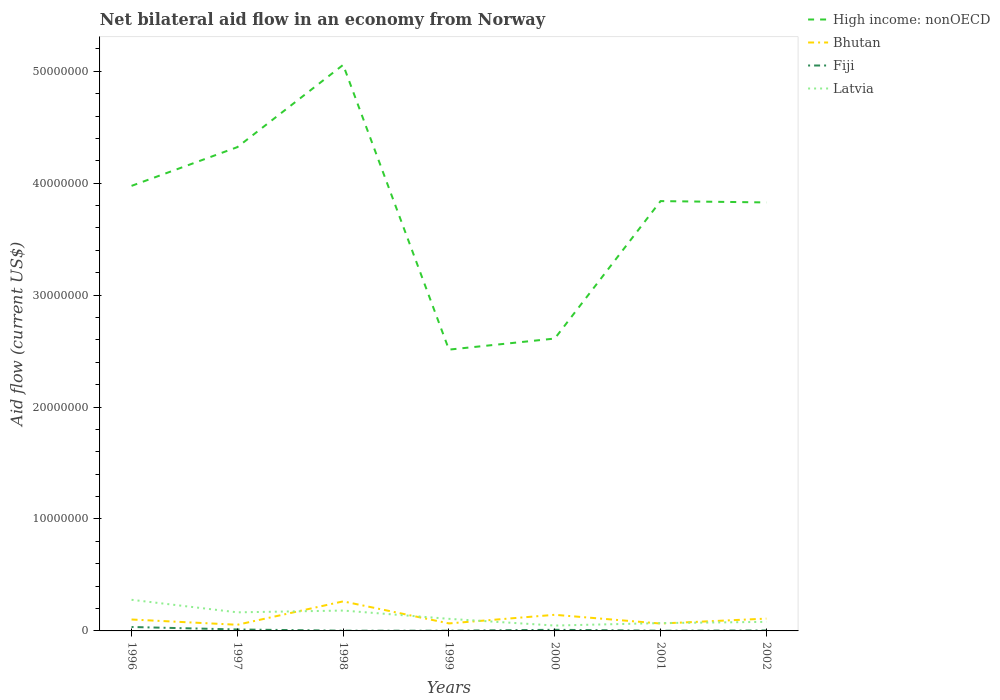Across all years, what is the maximum net bilateral aid flow in Bhutan?
Your response must be concise. 5.50e+05. In which year was the net bilateral aid flow in Bhutan maximum?
Offer a terse response. 1997. What is the total net bilateral aid flow in Fiji in the graph?
Offer a very short reply. 8.00e+04. What is the difference between the highest and the second highest net bilateral aid flow in Latvia?
Make the answer very short. 2.30e+06. How many lines are there?
Make the answer very short. 4. How many years are there in the graph?
Offer a very short reply. 7. Are the values on the major ticks of Y-axis written in scientific E-notation?
Offer a very short reply. No. Does the graph contain any zero values?
Make the answer very short. No. Does the graph contain grids?
Your answer should be compact. No. How many legend labels are there?
Ensure brevity in your answer.  4. What is the title of the graph?
Your answer should be compact. Net bilateral aid flow in an economy from Norway. Does "Switzerland" appear as one of the legend labels in the graph?
Your answer should be very brief. No. What is the label or title of the X-axis?
Offer a very short reply. Years. What is the Aid flow (current US$) of High income: nonOECD in 1996?
Your response must be concise. 3.98e+07. What is the Aid flow (current US$) of Bhutan in 1996?
Provide a short and direct response. 1.02e+06. What is the Aid flow (current US$) in Latvia in 1996?
Keep it short and to the point. 2.78e+06. What is the Aid flow (current US$) of High income: nonOECD in 1997?
Provide a succinct answer. 4.32e+07. What is the Aid flow (current US$) of Bhutan in 1997?
Provide a succinct answer. 5.50e+05. What is the Aid flow (current US$) in Latvia in 1997?
Your answer should be compact. 1.66e+06. What is the Aid flow (current US$) in High income: nonOECD in 1998?
Provide a short and direct response. 5.06e+07. What is the Aid flow (current US$) of Bhutan in 1998?
Give a very brief answer. 2.64e+06. What is the Aid flow (current US$) of Fiji in 1998?
Ensure brevity in your answer.  2.00e+04. What is the Aid flow (current US$) in Latvia in 1998?
Offer a very short reply. 1.82e+06. What is the Aid flow (current US$) of High income: nonOECD in 1999?
Make the answer very short. 2.51e+07. What is the Aid flow (current US$) in Bhutan in 1999?
Give a very brief answer. 6.70e+05. What is the Aid flow (current US$) of Fiji in 1999?
Make the answer very short. 2.00e+04. What is the Aid flow (current US$) of Latvia in 1999?
Offer a terse response. 1.08e+06. What is the Aid flow (current US$) of High income: nonOECD in 2000?
Your answer should be compact. 2.61e+07. What is the Aid flow (current US$) in Bhutan in 2000?
Your answer should be very brief. 1.44e+06. What is the Aid flow (current US$) in Fiji in 2000?
Offer a terse response. 1.00e+05. What is the Aid flow (current US$) in High income: nonOECD in 2001?
Offer a terse response. 3.84e+07. What is the Aid flow (current US$) of Bhutan in 2001?
Keep it short and to the point. 6.60e+05. What is the Aid flow (current US$) of Fiji in 2001?
Your answer should be compact. 2.00e+04. What is the Aid flow (current US$) in Latvia in 2001?
Give a very brief answer. 7.00e+05. What is the Aid flow (current US$) in High income: nonOECD in 2002?
Your response must be concise. 3.83e+07. What is the Aid flow (current US$) in Bhutan in 2002?
Offer a very short reply. 1.10e+06. What is the Aid flow (current US$) of Fiji in 2002?
Make the answer very short. 4.00e+04. What is the Aid flow (current US$) in Latvia in 2002?
Your answer should be compact. 8.10e+05. Across all years, what is the maximum Aid flow (current US$) in High income: nonOECD?
Ensure brevity in your answer.  5.06e+07. Across all years, what is the maximum Aid flow (current US$) in Bhutan?
Offer a terse response. 2.64e+06. Across all years, what is the maximum Aid flow (current US$) of Fiji?
Your answer should be compact. 3.50e+05. Across all years, what is the maximum Aid flow (current US$) in Latvia?
Your response must be concise. 2.78e+06. Across all years, what is the minimum Aid flow (current US$) of High income: nonOECD?
Your response must be concise. 2.51e+07. Across all years, what is the minimum Aid flow (current US$) of Bhutan?
Make the answer very short. 5.50e+05. Across all years, what is the minimum Aid flow (current US$) in Fiji?
Give a very brief answer. 2.00e+04. Across all years, what is the minimum Aid flow (current US$) in Latvia?
Your answer should be very brief. 4.80e+05. What is the total Aid flow (current US$) of High income: nonOECD in the graph?
Your answer should be very brief. 2.61e+08. What is the total Aid flow (current US$) of Bhutan in the graph?
Offer a terse response. 8.08e+06. What is the total Aid flow (current US$) in Fiji in the graph?
Offer a very short reply. 6.80e+05. What is the total Aid flow (current US$) in Latvia in the graph?
Give a very brief answer. 9.33e+06. What is the difference between the Aid flow (current US$) of High income: nonOECD in 1996 and that in 1997?
Give a very brief answer. -3.46e+06. What is the difference between the Aid flow (current US$) in Bhutan in 1996 and that in 1997?
Give a very brief answer. 4.70e+05. What is the difference between the Aid flow (current US$) of Latvia in 1996 and that in 1997?
Your answer should be compact. 1.12e+06. What is the difference between the Aid flow (current US$) of High income: nonOECD in 1996 and that in 1998?
Offer a very short reply. -1.08e+07. What is the difference between the Aid flow (current US$) in Bhutan in 1996 and that in 1998?
Offer a terse response. -1.62e+06. What is the difference between the Aid flow (current US$) in Latvia in 1996 and that in 1998?
Keep it short and to the point. 9.60e+05. What is the difference between the Aid flow (current US$) of High income: nonOECD in 1996 and that in 1999?
Make the answer very short. 1.46e+07. What is the difference between the Aid flow (current US$) in Fiji in 1996 and that in 1999?
Give a very brief answer. 3.30e+05. What is the difference between the Aid flow (current US$) in Latvia in 1996 and that in 1999?
Provide a short and direct response. 1.70e+06. What is the difference between the Aid flow (current US$) in High income: nonOECD in 1996 and that in 2000?
Give a very brief answer. 1.36e+07. What is the difference between the Aid flow (current US$) of Bhutan in 1996 and that in 2000?
Offer a very short reply. -4.20e+05. What is the difference between the Aid flow (current US$) of Latvia in 1996 and that in 2000?
Give a very brief answer. 2.30e+06. What is the difference between the Aid flow (current US$) of High income: nonOECD in 1996 and that in 2001?
Keep it short and to the point. 1.36e+06. What is the difference between the Aid flow (current US$) in Bhutan in 1996 and that in 2001?
Offer a very short reply. 3.60e+05. What is the difference between the Aid flow (current US$) of Fiji in 1996 and that in 2001?
Provide a short and direct response. 3.30e+05. What is the difference between the Aid flow (current US$) in Latvia in 1996 and that in 2001?
Your answer should be compact. 2.08e+06. What is the difference between the Aid flow (current US$) in High income: nonOECD in 1996 and that in 2002?
Your answer should be very brief. 1.48e+06. What is the difference between the Aid flow (current US$) in Bhutan in 1996 and that in 2002?
Offer a terse response. -8.00e+04. What is the difference between the Aid flow (current US$) of Fiji in 1996 and that in 2002?
Provide a succinct answer. 3.10e+05. What is the difference between the Aid flow (current US$) of Latvia in 1996 and that in 2002?
Give a very brief answer. 1.97e+06. What is the difference between the Aid flow (current US$) of High income: nonOECD in 1997 and that in 1998?
Your answer should be compact. -7.35e+06. What is the difference between the Aid flow (current US$) in Bhutan in 1997 and that in 1998?
Offer a very short reply. -2.09e+06. What is the difference between the Aid flow (current US$) in Fiji in 1997 and that in 1998?
Offer a terse response. 1.10e+05. What is the difference between the Aid flow (current US$) in High income: nonOECD in 1997 and that in 1999?
Ensure brevity in your answer.  1.81e+07. What is the difference between the Aid flow (current US$) of Bhutan in 1997 and that in 1999?
Provide a short and direct response. -1.20e+05. What is the difference between the Aid flow (current US$) of Fiji in 1997 and that in 1999?
Your answer should be compact. 1.10e+05. What is the difference between the Aid flow (current US$) in Latvia in 1997 and that in 1999?
Provide a short and direct response. 5.80e+05. What is the difference between the Aid flow (current US$) of High income: nonOECD in 1997 and that in 2000?
Provide a succinct answer. 1.71e+07. What is the difference between the Aid flow (current US$) in Bhutan in 1997 and that in 2000?
Your response must be concise. -8.90e+05. What is the difference between the Aid flow (current US$) in Latvia in 1997 and that in 2000?
Provide a short and direct response. 1.18e+06. What is the difference between the Aid flow (current US$) of High income: nonOECD in 1997 and that in 2001?
Your answer should be very brief. 4.82e+06. What is the difference between the Aid flow (current US$) in Fiji in 1997 and that in 2001?
Keep it short and to the point. 1.10e+05. What is the difference between the Aid flow (current US$) of Latvia in 1997 and that in 2001?
Offer a terse response. 9.60e+05. What is the difference between the Aid flow (current US$) in High income: nonOECD in 1997 and that in 2002?
Offer a terse response. 4.94e+06. What is the difference between the Aid flow (current US$) in Bhutan in 1997 and that in 2002?
Offer a very short reply. -5.50e+05. What is the difference between the Aid flow (current US$) of Latvia in 1997 and that in 2002?
Offer a terse response. 8.50e+05. What is the difference between the Aid flow (current US$) in High income: nonOECD in 1998 and that in 1999?
Ensure brevity in your answer.  2.54e+07. What is the difference between the Aid flow (current US$) of Bhutan in 1998 and that in 1999?
Provide a succinct answer. 1.97e+06. What is the difference between the Aid flow (current US$) in Fiji in 1998 and that in 1999?
Your response must be concise. 0. What is the difference between the Aid flow (current US$) of Latvia in 1998 and that in 1999?
Offer a very short reply. 7.40e+05. What is the difference between the Aid flow (current US$) of High income: nonOECD in 1998 and that in 2000?
Keep it short and to the point. 2.44e+07. What is the difference between the Aid flow (current US$) in Bhutan in 1998 and that in 2000?
Make the answer very short. 1.20e+06. What is the difference between the Aid flow (current US$) of Latvia in 1998 and that in 2000?
Provide a succinct answer. 1.34e+06. What is the difference between the Aid flow (current US$) in High income: nonOECD in 1998 and that in 2001?
Provide a succinct answer. 1.22e+07. What is the difference between the Aid flow (current US$) of Bhutan in 1998 and that in 2001?
Your answer should be compact. 1.98e+06. What is the difference between the Aid flow (current US$) in Fiji in 1998 and that in 2001?
Your answer should be compact. 0. What is the difference between the Aid flow (current US$) of Latvia in 1998 and that in 2001?
Ensure brevity in your answer.  1.12e+06. What is the difference between the Aid flow (current US$) in High income: nonOECD in 1998 and that in 2002?
Your answer should be very brief. 1.23e+07. What is the difference between the Aid flow (current US$) of Bhutan in 1998 and that in 2002?
Provide a short and direct response. 1.54e+06. What is the difference between the Aid flow (current US$) in Fiji in 1998 and that in 2002?
Your response must be concise. -2.00e+04. What is the difference between the Aid flow (current US$) in Latvia in 1998 and that in 2002?
Provide a short and direct response. 1.01e+06. What is the difference between the Aid flow (current US$) of High income: nonOECD in 1999 and that in 2000?
Give a very brief answer. -9.90e+05. What is the difference between the Aid flow (current US$) of Bhutan in 1999 and that in 2000?
Give a very brief answer. -7.70e+05. What is the difference between the Aid flow (current US$) in Fiji in 1999 and that in 2000?
Make the answer very short. -8.00e+04. What is the difference between the Aid flow (current US$) of High income: nonOECD in 1999 and that in 2001?
Provide a succinct answer. -1.33e+07. What is the difference between the Aid flow (current US$) in Fiji in 1999 and that in 2001?
Make the answer very short. 0. What is the difference between the Aid flow (current US$) of Latvia in 1999 and that in 2001?
Make the answer very short. 3.80e+05. What is the difference between the Aid flow (current US$) in High income: nonOECD in 1999 and that in 2002?
Make the answer very short. -1.32e+07. What is the difference between the Aid flow (current US$) in Bhutan in 1999 and that in 2002?
Offer a terse response. -4.30e+05. What is the difference between the Aid flow (current US$) in Fiji in 1999 and that in 2002?
Give a very brief answer. -2.00e+04. What is the difference between the Aid flow (current US$) in Latvia in 1999 and that in 2002?
Provide a short and direct response. 2.70e+05. What is the difference between the Aid flow (current US$) of High income: nonOECD in 2000 and that in 2001?
Ensure brevity in your answer.  -1.23e+07. What is the difference between the Aid flow (current US$) of Bhutan in 2000 and that in 2001?
Give a very brief answer. 7.80e+05. What is the difference between the Aid flow (current US$) of Latvia in 2000 and that in 2001?
Provide a succinct answer. -2.20e+05. What is the difference between the Aid flow (current US$) of High income: nonOECD in 2000 and that in 2002?
Ensure brevity in your answer.  -1.22e+07. What is the difference between the Aid flow (current US$) of Bhutan in 2000 and that in 2002?
Your answer should be compact. 3.40e+05. What is the difference between the Aid flow (current US$) of Fiji in 2000 and that in 2002?
Ensure brevity in your answer.  6.00e+04. What is the difference between the Aid flow (current US$) in Latvia in 2000 and that in 2002?
Your answer should be compact. -3.30e+05. What is the difference between the Aid flow (current US$) of Bhutan in 2001 and that in 2002?
Your answer should be compact. -4.40e+05. What is the difference between the Aid flow (current US$) in Fiji in 2001 and that in 2002?
Provide a short and direct response. -2.00e+04. What is the difference between the Aid flow (current US$) of Latvia in 2001 and that in 2002?
Keep it short and to the point. -1.10e+05. What is the difference between the Aid flow (current US$) of High income: nonOECD in 1996 and the Aid flow (current US$) of Bhutan in 1997?
Your response must be concise. 3.92e+07. What is the difference between the Aid flow (current US$) in High income: nonOECD in 1996 and the Aid flow (current US$) in Fiji in 1997?
Your answer should be very brief. 3.96e+07. What is the difference between the Aid flow (current US$) of High income: nonOECD in 1996 and the Aid flow (current US$) of Latvia in 1997?
Your response must be concise. 3.81e+07. What is the difference between the Aid flow (current US$) in Bhutan in 1996 and the Aid flow (current US$) in Fiji in 1997?
Keep it short and to the point. 8.90e+05. What is the difference between the Aid flow (current US$) of Bhutan in 1996 and the Aid flow (current US$) of Latvia in 1997?
Your answer should be compact. -6.40e+05. What is the difference between the Aid flow (current US$) of Fiji in 1996 and the Aid flow (current US$) of Latvia in 1997?
Your answer should be very brief. -1.31e+06. What is the difference between the Aid flow (current US$) of High income: nonOECD in 1996 and the Aid flow (current US$) of Bhutan in 1998?
Your answer should be compact. 3.71e+07. What is the difference between the Aid flow (current US$) of High income: nonOECD in 1996 and the Aid flow (current US$) of Fiji in 1998?
Provide a succinct answer. 3.97e+07. What is the difference between the Aid flow (current US$) of High income: nonOECD in 1996 and the Aid flow (current US$) of Latvia in 1998?
Your answer should be very brief. 3.79e+07. What is the difference between the Aid flow (current US$) of Bhutan in 1996 and the Aid flow (current US$) of Latvia in 1998?
Provide a short and direct response. -8.00e+05. What is the difference between the Aid flow (current US$) of Fiji in 1996 and the Aid flow (current US$) of Latvia in 1998?
Provide a succinct answer. -1.47e+06. What is the difference between the Aid flow (current US$) of High income: nonOECD in 1996 and the Aid flow (current US$) of Bhutan in 1999?
Provide a short and direct response. 3.91e+07. What is the difference between the Aid flow (current US$) in High income: nonOECD in 1996 and the Aid flow (current US$) in Fiji in 1999?
Your response must be concise. 3.97e+07. What is the difference between the Aid flow (current US$) in High income: nonOECD in 1996 and the Aid flow (current US$) in Latvia in 1999?
Ensure brevity in your answer.  3.87e+07. What is the difference between the Aid flow (current US$) in Fiji in 1996 and the Aid flow (current US$) in Latvia in 1999?
Provide a short and direct response. -7.30e+05. What is the difference between the Aid flow (current US$) of High income: nonOECD in 1996 and the Aid flow (current US$) of Bhutan in 2000?
Give a very brief answer. 3.83e+07. What is the difference between the Aid flow (current US$) in High income: nonOECD in 1996 and the Aid flow (current US$) in Fiji in 2000?
Offer a very short reply. 3.97e+07. What is the difference between the Aid flow (current US$) of High income: nonOECD in 1996 and the Aid flow (current US$) of Latvia in 2000?
Make the answer very short. 3.93e+07. What is the difference between the Aid flow (current US$) of Bhutan in 1996 and the Aid flow (current US$) of Fiji in 2000?
Your answer should be compact. 9.20e+05. What is the difference between the Aid flow (current US$) in Bhutan in 1996 and the Aid flow (current US$) in Latvia in 2000?
Ensure brevity in your answer.  5.40e+05. What is the difference between the Aid flow (current US$) in Fiji in 1996 and the Aid flow (current US$) in Latvia in 2000?
Provide a short and direct response. -1.30e+05. What is the difference between the Aid flow (current US$) in High income: nonOECD in 1996 and the Aid flow (current US$) in Bhutan in 2001?
Offer a very short reply. 3.91e+07. What is the difference between the Aid flow (current US$) in High income: nonOECD in 1996 and the Aid flow (current US$) in Fiji in 2001?
Give a very brief answer. 3.97e+07. What is the difference between the Aid flow (current US$) of High income: nonOECD in 1996 and the Aid flow (current US$) of Latvia in 2001?
Provide a short and direct response. 3.91e+07. What is the difference between the Aid flow (current US$) in Fiji in 1996 and the Aid flow (current US$) in Latvia in 2001?
Offer a terse response. -3.50e+05. What is the difference between the Aid flow (current US$) in High income: nonOECD in 1996 and the Aid flow (current US$) in Bhutan in 2002?
Make the answer very short. 3.87e+07. What is the difference between the Aid flow (current US$) of High income: nonOECD in 1996 and the Aid flow (current US$) of Fiji in 2002?
Ensure brevity in your answer.  3.97e+07. What is the difference between the Aid flow (current US$) in High income: nonOECD in 1996 and the Aid flow (current US$) in Latvia in 2002?
Your response must be concise. 3.90e+07. What is the difference between the Aid flow (current US$) of Bhutan in 1996 and the Aid flow (current US$) of Fiji in 2002?
Your answer should be compact. 9.80e+05. What is the difference between the Aid flow (current US$) of Fiji in 1996 and the Aid flow (current US$) of Latvia in 2002?
Ensure brevity in your answer.  -4.60e+05. What is the difference between the Aid flow (current US$) of High income: nonOECD in 1997 and the Aid flow (current US$) of Bhutan in 1998?
Make the answer very short. 4.06e+07. What is the difference between the Aid flow (current US$) of High income: nonOECD in 1997 and the Aid flow (current US$) of Fiji in 1998?
Provide a short and direct response. 4.32e+07. What is the difference between the Aid flow (current US$) of High income: nonOECD in 1997 and the Aid flow (current US$) of Latvia in 1998?
Keep it short and to the point. 4.14e+07. What is the difference between the Aid flow (current US$) in Bhutan in 1997 and the Aid flow (current US$) in Fiji in 1998?
Your answer should be very brief. 5.30e+05. What is the difference between the Aid flow (current US$) of Bhutan in 1997 and the Aid flow (current US$) of Latvia in 1998?
Your answer should be very brief. -1.27e+06. What is the difference between the Aid flow (current US$) of Fiji in 1997 and the Aid flow (current US$) of Latvia in 1998?
Your answer should be very brief. -1.69e+06. What is the difference between the Aid flow (current US$) in High income: nonOECD in 1997 and the Aid flow (current US$) in Bhutan in 1999?
Offer a terse response. 4.26e+07. What is the difference between the Aid flow (current US$) in High income: nonOECD in 1997 and the Aid flow (current US$) in Fiji in 1999?
Your answer should be very brief. 4.32e+07. What is the difference between the Aid flow (current US$) of High income: nonOECD in 1997 and the Aid flow (current US$) of Latvia in 1999?
Your answer should be very brief. 4.21e+07. What is the difference between the Aid flow (current US$) of Bhutan in 1997 and the Aid flow (current US$) of Fiji in 1999?
Provide a succinct answer. 5.30e+05. What is the difference between the Aid flow (current US$) of Bhutan in 1997 and the Aid flow (current US$) of Latvia in 1999?
Keep it short and to the point. -5.30e+05. What is the difference between the Aid flow (current US$) in Fiji in 1997 and the Aid flow (current US$) in Latvia in 1999?
Keep it short and to the point. -9.50e+05. What is the difference between the Aid flow (current US$) in High income: nonOECD in 1997 and the Aid flow (current US$) in Bhutan in 2000?
Provide a short and direct response. 4.18e+07. What is the difference between the Aid flow (current US$) of High income: nonOECD in 1997 and the Aid flow (current US$) of Fiji in 2000?
Ensure brevity in your answer.  4.31e+07. What is the difference between the Aid flow (current US$) in High income: nonOECD in 1997 and the Aid flow (current US$) in Latvia in 2000?
Ensure brevity in your answer.  4.27e+07. What is the difference between the Aid flow (current US$) in Bhutan in 1997 and the Aid flow (current US$) in Latvia in 2000?
Your answer should be compact. 7.00e+04. What is the difference between the Aid flow (current US$) of Fiji in 1997 and the Aid flow (current US$) of Latvia in 2000?
Offer a very short reply. -3.50e+05. What is the difference between the Aid flow (current US$) in High income: nonOECD in 1997 and the Aid flow (current US$) in Bhutan in 2001?
Offer a very short reply. 4.26e+07. What is the difference between the Aid flow (current US$) in High income: nonOECD in 1997 and the Aid flow (current US$) in Fiji in 2001?
Offer a very short reply. 4.32e+07. What is the difference between the Aid flow (current US$) of High income: nonOECD in 1997 and the Aid flow (current US$) of Latvia in 2001?
Provide a succinct answer. 4.25e+07. What is the difference between the Aid flow (current US$) in Bhutan in 1997 and the Aid flow (current US$) in Fiji in 2001?
Give a very brief answer. 5.30e+05. What is the difference between the Aid flow (current US$) of Fiji in 1997 and the Aid flow (current US$) of Latvia in 2001?
Ensure brevity in your answer.  -5.70e+05. What is the difference between the Aid flow (current US$) in High income: nonOECD in 1997 and the Aid flow (current US$) in Bhutan in 2002?
Offer a very short reply. 4.21e+07. What is the difference between the Aid flow (current US$) of High income: nonOECD in 1997 and the Aid flow (current US$) of Fiji in 2002?
Your answer should be very brief. 4.32e+07. What is the difference between the Aid flow (current US$) in High income: nonOECD in 1997 and the Aid flow (current US$) in Latvia in 2002?
Your answer should be very brief. 4.24e+07. What is the difference between the Aid flow (current US$) of Bhutan in 1997 and the Aid flow (current US$) of Fiji in 2002?
Give a very brief answer. 5.10e+05. What is the difference between the Aid flow (current US$) in Fiji in 1997 and the Aid flow (current US$) in Latvia in 2002?
Your answer should be very brief. -6.80e+05. What is the difference between the Aid flow (current US$) in High income: nonOECD in 1998 and the Aid flow (current US$) in Bhutan in 1999?
Offer a very short reply. 4.99e+07. What is the difference between the Aid flow (current US$) in High income: nonOECD in 1998 and the Aid flow (current US$) in Fiji in 1999?
Ensure brevity in your answer.  5.06e+07. What is the difference between the Aid flow (current US$) in High income: nonOECD in 1998 and the Aid flow (current US$) in Latvia in 1999?
Provide a succinct answer. 4.95e+07. What is the difference between the Aid flow (current US$) in Bhutan in 1998 and the Aid flow (current US$) in Fiji in 1999?
Offer a terse response. 2.62e+06. What is the difference between the Aid flow (current US$) of Bhutan in 1998 and the Aid flow (current US$) of Latvia in 1999?
Offer a terse response. 1.56e+06. What is the difference between the Aid flow (current US$) in Fiji in 1998 and the Aid flow (current US$) in Latvia in 1999?
Make the answer very short. -1.06e+06. What is the difference between the Aid flow (current US$) of High income: nonOECD in 1998 and the Aid flow (current US$) of Bhutan in 2000?
Provide a short and direct response. 4.91e+07. What is the difference between the Aid flow (current US$) of High income: nonOECD in 1998 and the Aid flow (current US$) of Fiji in 2000?
Make the answer very short. 5.05e+07. What is the difference between the Aid flow (current US$) of High income: nonOECD in 1998 and the Aid flow (current US$) of Latvia in 2000?
Ensure brevity in your answer.  5.01e+07. What is the difference between the Aid flow (current US$) in Bhutan in 1998 and the Aid flow (current US$) in Fiji in 2000?
Provide a short and direct response. 2.54e+06. What is the difference between the Aid flow (current US$) in Bhutan in 1998 and the Aid flow (current US$) in Latvia in 2000?
Make the answer very short. 2.16e+06. What is the difference between the Aid flow (current US$) in Fiji in 1998 and the Aid flow (current US$) in Latvia in 2000?
Offer a very short reply. -4.60e+05. What is the difference between the Aid flow (current US$) of High income: nonOECD in 1998 and the Aid flow (current US$) of Bhutan in 2001?
Your response must be concise. 4.99e+07. What is the difference between the Aid flow (current US$) of High income: nonOECD in 1998 and the Aid flow (current US$) of Fiji in 2001?
Offer a terse response. 5.06e+07. What is the difference between the Aid flow (current US$) in High income: nonOECD in 1998 and the Aid flow (current US$) in Latvia in 2001?
Keep it short and to the point. 4.99e+07. What is the difference between the Aid flow (current US$) in Bhutan in 1998 and the Aid flow (current US$) in Fiji in 2001?
Offer a terse response. 2.62e+06. What is the difference between the Aid flow (current US$) of Bhutan in 1998 and the Aid flow (current US$) of Latvia in 2001?
Ensure brevity in your answer.  1.94e+06. What is the difference between the Aid flow (current US$) in Fiji in 1998 and the Aid flow (current US$) in Latvia in 2001?
Provide a succinct answer. -6.80e+05. What is the difference between the Aid flow (current US$) in High income: nonOECD in 1998 and the Aid flow (current US$) in Bhutan in 2002?
Your answer should be very brief. 4.95e+07. What is the difference between the Aid flow (current US$) of High income: nonOECD in 1998 and the Aid flow (current US$) of Fiji in 2002?
Your answer should be compact. 5.05e+07. What is the difference between the Aid flow (current US$) of High income: nonOECD in 1998 and the Aid flow (current US$) of Latvia in 2002?
Provide a succinct answer. 4.98e+07. What is the difference between the Aid flow (current US$) in Bhutan in 1998 and the Aid flow (current US$) in Fiji in 2002?
Your response must be concise. 2.60e+06. What is the difference between the Aid flow (current US$) in Bhutan in 1998 and the Aid flow (current US$) in Latvia in 2002?
Your response must be concise. 1.83e+06. What is the difference between the Aid flow (current US$) of Fiji in 1998 and the Aid flow (current US$) of Latvia in 2002?
Your answer should be compact. -7.90e+05. What is the difference between the Aid flow (current US$) in High income: nonOECD in 1999 and the Aid flow (current US$) in Bhutan in 2000?
Offer a terse response. 2.37e+07. What is the difference between the Aid flow (current US$) of High income: nonOECD in 1999 and the Aid flow (current US$) of Fiji in 2000?
Make the answer very short. 2.50e+07. What is the difference between the Aid flow (current US$) of High income: nonOECD in 1999 and the Aid flow (current US$) of Latvia in 2000?
Your answer should be very brief. 2.46e+07. What is the difference between the Aid flow (current US$) of Bhutan in 1999 and the Aid flow (current US$) of Fiji in 2000?
Provide a short and direct response. 5.70e+05. What is the difference between the Aid flow (current US$) in Bhutan in 1999 and the Aid flow (current US$) in Latvia in 2000?
Your answer should be very brief. 1.90e+05. What is the difference between the Aid flow (current US$) of Fiji in 1999 and the Aid flow (current US$) of Latvia in 2000?
Your response must be concise. -4.60e+05. What is the difference between the Aid flow (current US$) in High income: nonOECD in 1999 and the Aid flow (current US$) in Bhutan in 2001?
Offer a very short reply. 2.45e+07. What is the difference between the Aid flow (current US$) in High income: nonOECD in 1999 and the Aid flow (current US$) in Fiji in 2001?
Provide a succinct answer. 2.51e+07. What is the difference between the Aid flow (current US$) of High income: nonOECD in 1999 and the Aid flow (current US$) of Latvia in 2001?
Your answer should be very brief. 2.44e+07. What is the difference between the Aid flow (current US$) of Bhutan in 1999 and the Aid flow (current US$) of Fiji in 2001?
Give a very brief answer. 6.50e+05. What is the difference between the Aid flow (current US$) of Fiji in 1999 and the Aid flow (current US$) of Latvia in 2001?
Your answer should be very brief. -6.80e+05. What is the difference between the Aid flow (current US$) of High income: nonOECD in 1999 and the Aid flow (current US$) of Bhutan in 2002?
Your answer should be compact. 2.40e+07. What is the difference between the Aid flow (current US$) of High income: nonOECD in 1999 and the Aid flow (current US$) of Fiji in 2002?
Offer a terse response. 2.51e+07. What is the difference between the Aid flow (current US$) in High income: nonOECD in 1999 and the Aid flow (current US$) in Latvia in 2002?
Provide a short and direct response. 2.43e+07. What is the difference between the Aid flow (current US$) in Bhutan in 1999 and the Aid flow (current US$) in Fiji in 2002?
Offer a terse response. 6.30e+05. What is the difference between the Aid flow (current US$) of Bhutan in 1999 and the Aid flow (current US$) of Latvia in 2002?
Keep it short and to the point. -1.40e+05. What is the difference between the Aid flow (current US$) in Fiji in 1999 and the Aid flow (current US$) in Latvia in 2002?
Offer a terse response. -7.90e+05. What is the difference between the Aid flow (current US$) of High income: nonOECD in 2000 and the Aid flow (current US$) of Bhutan in 2001?
Make the answer very short. 2.55e+07. What is the difference between the Aid flow (current US$) in High income: nonOECD in 2000 and the Aid flow (current US$) in Fiji in 2001?
Your answer should be compact. 2.61e+07. What is the difference between the Aid flow (current US$) of High income: nonOECD in 2000 and the Aid flow (current US$) of Latvia in 2001?
Make the answer very short. 2.54e+07. What is the difference between the Aid flow (current US$) in Bhutan in 2000 and the Aid flow (current US$) in Fiji in 2001?
Your answer should be very brief. 1.42e+06. What is the difference between the Aid flow (current US$) in Bhutan in 2000 and the Aid flow (current US$) in Latvia in 2001?
Offer a terse response. 7.40e+05. What is the difference between the Aid flow (current US$) of Fiji in 2000 and the Aid flow (current US$) of Latvia in 2001?
Your response must be concise. -6.00e+05. What is the difference between the Aid flow (current US$) in High income: nonOECD in 2000 and the Aid flow (current US$) in Bhutan in 2002?
Offer a very short reply. 2.50e+07. What is the difference between the Aid flow (current US$) in High income: nonOECD in 2000 and the Aid flow (current US$) in Fiji in 2002?
Ensure brevity in your answer.  2.61e+07. What is the difference between the Aid flow (current US$) in High income: nonOECD in 2000 and the Aid flow (current US$) in Latvia in 2002?
Make the answer very short. 2.53e+07. What is the difference between the Aid flow (current US$) in Bhutan in 2000 and the Aid flow (current US$) in Fiji in 2002?
Make the answer very short. 1.40e+06. What is the difference between the Aid flow (current US$) in Bhutan in 2000 and the Aid flow (current US$) in Latvia in 2002?
Your answer should be very brief. 6.30e+05. What is the difference between the Aid flow (current US$) in Fiji in 2000 and the Aid flow (current US$) in Latvia in 2002?
Your response must be concise. -7.10e+05. What is the difference between the Aid flow (current US$) of High income: nonOECD in 2001 and the Aid flow (current US$) of Bhutan in 2002?
Offer a very short reply. 3.73e+07. What is the difference between the Aid flow (current US$) of High income: nonOECD in 2001 and the Aid flow (current US$) of Fiji in 2002?
Provide a succinct answer. 3.84e+07. What is the difference between the Aid flow (current US$) of High income: nonOECD in 2001 and the Aid flow (current US$) of Latvia in 2002?
Ensure brevity in your answer.  3.76e+07. What is the difference between the Aid flow (current US$) in Bhutan in 2001 and the Aid flow (current US$) in Fiji in 2002?
Offer a very short reply. 6.20e+05. What is the difference between the Aid flow (current US$) in Fiji in 2001 and the Aid flow (current US$) in Latvia in 2002?
Offer a terse response. -7.90e+05. What is the average Aid flow (current US$) of High income: nonOECD per year?
Offer a very short reply. 3.74e+07. What is the average Aid flow (current US$) of Bhutan per year?
Offer a terse response. 1.15e+06. What is the average Aid flow (current US$) in Fiji per year?
Offer a very short reply. 9.71e+04. What is the average Aid flow (current US$) in Latvia per year?
Your answer should be compact. 1.33e+06. In the year 1996, what is the difference between the Aid flow (current US$) in High income: nonOECD and Aid flow (current US$) in Bhutan?
Give a very brief answer. 3.87e+07. In the year 1996, what is the difference between the Aid flow (current US$) of High income: nonOECD and Aid flow (current US$) of Fiji?
Ensure brevity in your answer.  3.94e+07. In the year 1996, what is the difference between the Aid flow (current US$) of High income: nonOECD and Aid flow (current US$) of Latvia?
Give a very brief answer. 3.70e+07. In the year 1996, what is the difference between the Aid flow (current US$) in Bhutan and Aid flow (current US$) in Fiji?
Your answer should be very brief. 6.70e+05. In the year 1996, what is the difference between the Aid flow (current US$) in Bhutan and Aid flow (current US$) in Latvia?
Offer a terse response. -1.76e+06. In the year 1996, what is the difference between the Aid flow (current US$) of Fiji and Aid flow (current US$) of Latvia?
Your answer should be compact. -2.43e+06. In the year 1997, what is the difference between the Aid flow (current US$) in High income: nonOECD and Aid flow (current US$) in Bhutan?
Keep it short and to the point. 4.27e+07. In the year 1997, what is the difference between the Aid flow (current US$) of High income: nonOECD and Aid flow (current US$) of Fiji?
Give a very brief answer. 4.31e+07. In the year 1997, what is the difference between the Aid flow (current US$) in High income: nonOECD and Aid flow (current US$) in Latvia?
Give a very brief answer. 4.16e+07. In the year 1997, what is the difference between the Aid flow (current US$) of Bhutan and Aid flow (current US$) of Latvia?
Offer a very short reply. -1.11e+06. In the year 1997, what is the difference between the Aid flow (current US$) in Fiji and Aid flow (current US$) in Latvia?
Give a very brief answer. -1.53e+06. In the year 1998, what is the difference between the Aid flow (current US$) of High income: nonOECD and Aid flow (current US$) of Bhutan?
Ensure brevity in your answer.  4.79e+07. In the year 1998, what is the difference between the Aid flow (current US$) in High income: nonOECD and Aid flow (current US$) in Fiji?
Your response must be concise. 5.06e+07. In the year 1998, what is the difference between the Aid flow (current US$) in High income: nonOECD and Aid flow (current US$) in Latvia?
Keep it short and to the point. 4.88e+07. In the year 1998, what is the difference between the Aid flow (current US$) of Bhutan and Aid flow (current US$) of Fiji?
Offer a terse response. 2.62e+06. In the year 1998, what is the difference between the Aid flow (current US$) in Bhutan and Aid flow (current US$) in Latvia?
Make the answer very short. 8.20e+05. In the year 1998, what is the difference between the Aid flow (current US$) of Fiji and Aid flow (current US$) of Latvia?
Keep it short and to the point. -1.80e+06. In the year 1999, what is the difference between the Aid flow (current US$) of High income: nonOECD and Aid flow (current US$) of Bhutan?
Your answer should be very brief. 2.45e+07. In the year 1999, what is the difference between the Aid flow (current US$) in High income: nonOECD and Aid flow (current US$) in Fiji?
Keep it short and to the point. 2.51e+07. In the year 1999, what is the difference between the Aid flow (current US$) in High income: nonOECD and Aid flow (current US$) in Latvia?
Provide a succinct answer. 2.40e+07. In the year 1999, what is the difference between the Aid flow (current US$) of Bhutan and Aid flow (current US$) of Fiji?
Make the answer very short. 6.50e+05. In the year 1999, what is the difference between the Aid flow (current US$) of Bhutan and Aid flow (current US$) of Latvia?
Ensure brevity in your answer.  -4.10e+05. In the year 1999, what is the difference between the Aid flow (current US$) in Fiji and Aid flow (current US$) in Latvia?
Provide a succinct answer. -1.06e+06. In the year 2000, what is the difference between the Aid flow (current US$) in High income: nonOECD and Aid flow (current US$) in Bhutan?
Offer a very short reply. 2.47e+07. In the year 2000, what is the difference between the Aid flow (current US$) of High income: nonOECD and Aid flow (current US$) of Fiji?
Provide a short and direct response. 2.60e+07. In the year 2000, what is the difference between the Aid flow (current US$) in High income: nonOECD and Aid flow (current US$) in Latvia?
Ensure brevity in your answer.  2.56e+07. In the year 2000, what is the difference between the Aid flow (current US$) in Bhutan and Aid flow (current US$) in Fiji?
Keep it short and to the point. 1.34e+06. In the year 2000, what is the difference between the Aid flow (current US$) of Bhutan and Aid flow (current US$) of Latvia?
Ensure brevity in your answer.  9.60e+05. In the year 2000, what is the difference between the Aid flow (current US$) of Fiji and Aid flow (current US$) of Latvia?
Provide a short and direct response. -3.80e+05. In the year 2001, what is the difference between the Aid flow (current US$) in High income: nonOECD and Aid flow (current US$) in Bhutan?
Provide a short and direct response. 3.77e+07. In the year 2001, what is the difference between the Aid flow (current US$) of High income: nonOECD and Aid flow (current US$) of Fiji?
Ensure brevity in your answer.  3.84e+07. In the year 2001, what is the difference between the Aid flow (current US$) of High income: nonOECD and Aid flow (current US$) of Latvia?
Offer a very short reply. 3.77e+07. In the year 2001, what is the difference between the Aid flow (current US$) of Bhutan and Aid flow (current US$) of Fiji?
Provide a succinct answer. 6.40e+05. In the year 2001, what is the difference between the Aid flow (current US$) in Fiji and Aid flow (current US$) in Latvia?
Your response must be concise. -6.80e+05. In the year 2002, what is the difference between the Aid flow (current US$) of High income: nonOECD and Aid flow (current US$) of Bhutan?
Offer a terse response. 3.72e+07. In the year 2002, what is the difference between the Aid flow (current US$) of High income: nonOECD and Aid flow (current US$) of Fiji?
Provide a succinct answer. 3.82e+07. In the year 2002, what is the difference between the Aid flow (current US$) in High income: nonOECD and Aid flow (current US$) in Latvia?
Provide a short and direct response. 3.75e+07. In the year 2002, what is the difference between the Aid flow (current US$) of Bhutan and Aid flow (current US$) of Fiji?
Offer a very short reply. 1.06e+06. In the year 2002, what is the difference between the Aid flow (current US$) in Bhutan and Aid flow (current US$) in Latvia?
Provide a short and direct response. 2.90e+05. In the year 2002, what is the difference between the Aid flow (current US$) in Fiji and Aid flow (current US$) in Latvia?
Give a very brief answer. -7.70e+05. What is the ratio of the Aid flow (current US$) of High income: nonOECD in 1996 to that in 1997?
Make the answer very short. 0.92. What is the ratio of the Aid flow (current US$) of Bhutan in 1996 to that in 1997?
Offer a terse response. 1.85. What is the ratio of the Aid flow (current US$) of Fiji in 1996 to that in 1997?
Provide a short and direct response. 2.69. What is the ratio of the Aid flow (current US$) in Latvia in 1996 to that in 1997?
Offer a terse response. 1.67. What is the ratio of the Aid flow (current US$) of High income: nonOECD in 1996 to that in 1998?
Your answer should be compact. 0.79. What is the ratio of the Aid flow (current US$) of Bhutan in 1996 to that in 1998?
Offer a very short reply. 0.39. What is the ratio of the Aid flow (current US$) in Latvia in 1996 to that in 1998?
Offer a terse response. 1.53. What is the ratio of the Aid flow (current US$) of High income: nonOECD in 1996 to that in 1999?
Provide a succinct answer. 1.58. What is the ratio of the Aid flow (current US$) in Bhutan in 1996 to that in 1999?
Your answer should be compact. 1.52. What is the ratio of the Aid flow (current US$) in Fiji in 1996 to that in 1999?
Offer a terse response. 17.5. What is the ratio of the Aid flow (current US$) in Latvia in 1996 to that in 1999?
Provide a short and direct response. 2.57. What is the ratio of the Aid flow (current US$) of High income: nonOECD in 1996 to that in 2000?
Your answer should be compact. 1.52. What is the ratio of the Aid flow (current US$) of Bhutan in 1996 to that in 2000?
Your answer should be compact. 0.71. What is the ratio of the Aid flow (current US$) in Latvia in 1996 to that in 2000?
Provide a succinct answer. 5.79. What is the ratio of the Aid flow (current US$) in High income: nonOECD in 1996 to that in 2001?
Your answer should be very brief. 1.04. What is the ratio of the Aid flow (current US$) in Bhutan in 1996 to that in 2001?
Offer a terse response. 1.55. What is the ratio of the Aid flow (current US$) in Fiji in 1996 to that in 2001?
Keep it short and to the point. 17.5. What is the ratio of the Aid flow (current US$) of Latvia in 1996 to that in 2001?
Give a very brief answer. 3.97. What is the ratio of the Aid flow (current US$) in High income: nonOECD in 1996 to that in 2002?
Keep it short and to the point. 1.04. What is the ratio of the Aid flow (current US$) of Bhutan in 1996 to that in 2002?
Your answer should be very brief. 0.93. What is the ratio of the Aid flow (current US$) in Fiji in 1996 to that in 2002?
Your answer should be compact. 8.75. What is the ratio of the Aid flow (current US$) in Latvia in 1996 to that in 2002?
Your response must be concise. 3.43. What is the ratio of the Aid flow (current US$) of High income: nonOECD in 1997 to that in 1998?
Offer a terse response. 0.85. What is the ratio of the Aid flow (current US$) in Bhutan in 1997 to that in 1998?
Give a very brief answer. 0.21. What is the ratio of the Aid flow (current US$) of Fiji in 1997 to that in 1998?
Give a very brief answer. 6.5. What is the ratio of the Aid flow (current US$) of Latvia in 1997 to that in 1998?
Provide a succinct answer. 0.91. What is the ratio of the Aid flow (current US$) in High income: nonOECD in 1997 to that in 1999?
Your answer should be compact. 1.72. What is the ratio of the Aid flow (current US$) in Bhutan in 1997 to that in 1999?
Make the answer very short. 0.82. What is the ratio of the Aid flow (current US$) in Fiji in 1997 to that in 1999?
Provide a succinct answer. 6.5. What is the ratio of the Aid flow (current US$) in Latvia in 1997 to that in 1999?
Your answer should be compact. 1.54. What is the ratio of the Aid flow (current US$) of High income: nonOECD in 1997 to that in 2000?
Offer a very short reply. 1.65. What is the ratio of the Aid flow (current US$) in Bhutan in 1997 to that in 2000?
Offer a very short reply. 0.38. What is the ratio of the Aid flow (current US$) in Latvia in 1997 to that in 2000?
Provide a short and direct response. 3.46. What is the ratio of the Aid flow (current US$) of High income: nonOECD in 1997 to that in 2001?
Your response must be concise. 1.13. What is the ratio of the Aid flow (current US$) in Bhutan in 1997 to that in 2001?
Keep it short and to the point. 0.83. What is the ratio of the Aid flow (current US$) of Latvia in 1997 to that in 2001?
Ensure brevity in your answer.  2.37. What is the ratio of the Aid flow (current US$) in High income: nonOECD in 1997 to that in 2002?
Your response must be concise. 1.13. What is the ratio of the Aid flow (current US$) of Fiji in 1997 to that in 2002?
Give a very brief answer. 3.25. What is the ratio of the Aid flow (current US$) in Latvia in 1997 to that in 2002?
Offer a very short reply. 2.05. What is the ratio of the Aid flow (current US$) in High income: nonOECD in 1998 to that in 1999?
Provide a short and direct response. 2.01. What is the ratio of the Aid flow (current US$) of Bhutan in 1998 to that in 1999?
Your answer should be very brief. 3.94. What is the ratio of the Aid flow (current US$) in Fiji in 1998 to that in 1999?
Keep it short and to the point. 1. What is the ratio of the Aid flow (current US$) of Latvia in 1998 to that in 1999?
Offer a very short reply. 1.69. What is the ratio of the Aid flow (current US$) of High income: nonOECD in 1998 to that in 2000?
Make the answer very short. 1.94. What is the ratio of the Aid flow (current US$) of Bhutan in 1998 to that in 2000?
Offer a terse response. 1.83. What is the ratio of the Aid flow (current US$) of Latvia in 1998 to that in 2000?
Provide a short and direct response. 3.79. What is the ratio of the Aid flow (current US$) of High income: nonOECD in 1998 to that in 2001?
Offer a terse response. 1.32. What is the ratio of the Aid flow (current US$) in Bhutan in 1998 to that in 2001?
Offer a terse response. 4. What is the ratio of the Aid flow (current US$) of Fiji in 1998 to that in 2001?
Your response must be concise. 1. What is the ratio of the Aid flow (current US$) of High income: nonOECD in 1998 to that in 2002?
Offer a very short reply. 1.32. What is the ratio of the Aid flow (current US$) in Bhutan in 1998 to that in 2002?
Provide a short and direct response. 2.4. What is the ratio of the Aid flow (current US$) in Fiji in 1998 to that in 2002?
Provide a succinct answer. 0.5. What is the ratio of the Aid flow (current US$) of Latvia in 1998 to that in 2002?
Ensure brevity in your answer.  2.25. What is the ratio of the Aid flow (current US$) in High income: nonOECD in 1999 to that in 2000?
Your answer should be compact. 0.96. What is the ratio of the Aid flow (current US$) in Bhutan in 1999 to that in 2000?
Your answer should be very brief. 0.47. What is the ratio of the Aid flow (current US$) of Fiji in 1999 to that in 2000?
Offer a terse response. 0.2. What is the ratio of the Aid flow (current US$) in Latvia in 1999 to that in 2000?
Your answer should be very brief. 2.25. What is the ratio of the Aid flow (current US$) in High income: nonOECD in 1999 to that in 2001?
Provide a short and direct response. 0.65. What is the ratio of the Aid flow (current US$) in Bhutan in 1999 to that in 2001?
Your answer should be compact. 1.02. What is the ratio of the Aid flow (current US$) of Fiji in 1999 to that in 2001?
Provide a succinct answer. 1. What is the ratio of the Aid flow (current US$) of Latvia in 1999 to that in 2001?
Offer a very short reply. 1.54. What is the ratio of the Aid flow (current US$) of High income: nonOECD in 1999 to that in 2002?
Offer a terse response. 0.66. What is the ratio of the Aid flow (current US$) of Bhutan in 1999 to that in 2002?
Provide a short and direct response. 0.61. What is the ratio of the Aid flow (current US$) of High income: nonOECD in 2000 to that in 2001?
Your answer should be compact. 0.68. What is the ratio of the Aid flow (current US$) of Bhutan in 2000 to that in 2001?
Keep it short and to the point. 2.18. What is the ratio of the Aid flow (current US$) of Latvia in 2000 to that in 2001?
Provide a short and direct response. 0.69. What is the ratio of the Aid flow (current US$) of High income: nonOECD in 2000 to that in 2002?
Your response must be concise. 0.68. What is the ratio of the Aid flow (current US$) of Bhutan in 2000 to that in 2002?
Your answer should be very brief. 1.31. What is the ratio of the Aid flow (current US$) of Latvia in 2000 to that in 2002?
Your answer should be very brief. 0.59. What is the ratio of the Aid flow (current US$) in Bhutan in 2001 to that in 2002?
Provide a succinct answer. 0.6. What is the ratio of the Aid flow (current US$) in Latvia in 2001 to that in 2002?
Provide a short and direct response. 0.86. What is the difference between the highest and the second highest Aid flow (current US$) of High income: nonOECD?
Keep it short and to the point. 7.35e+06. What is the difference between the highest and the second highest Aid flow (current US$) in Bhutan?
Your response must be concise. 1.20e+06. What is the difference between the highest and the second highest Aid flow (current US$) in Latvia?
Give a very brief answer. 9.60e+05. What is the difference between the highest and the lowest Aid flow (current US$) in High income: nonOECD?
Your answer should be very brief. 2.54e+07. What is the difference between the highest and the lowest Aid flow (current US$) in Bhutan?
Your response must be concise. 2.09e+06. What is the difference between the highest and the lowest Aid flow (current US$) in Fiji?
Offer a very short reply. 3.30e+05. What is the difference between the highest and the lowest Aid flow (current US$) in Latvia?
Offer a very short reply. 2.30e+06. 